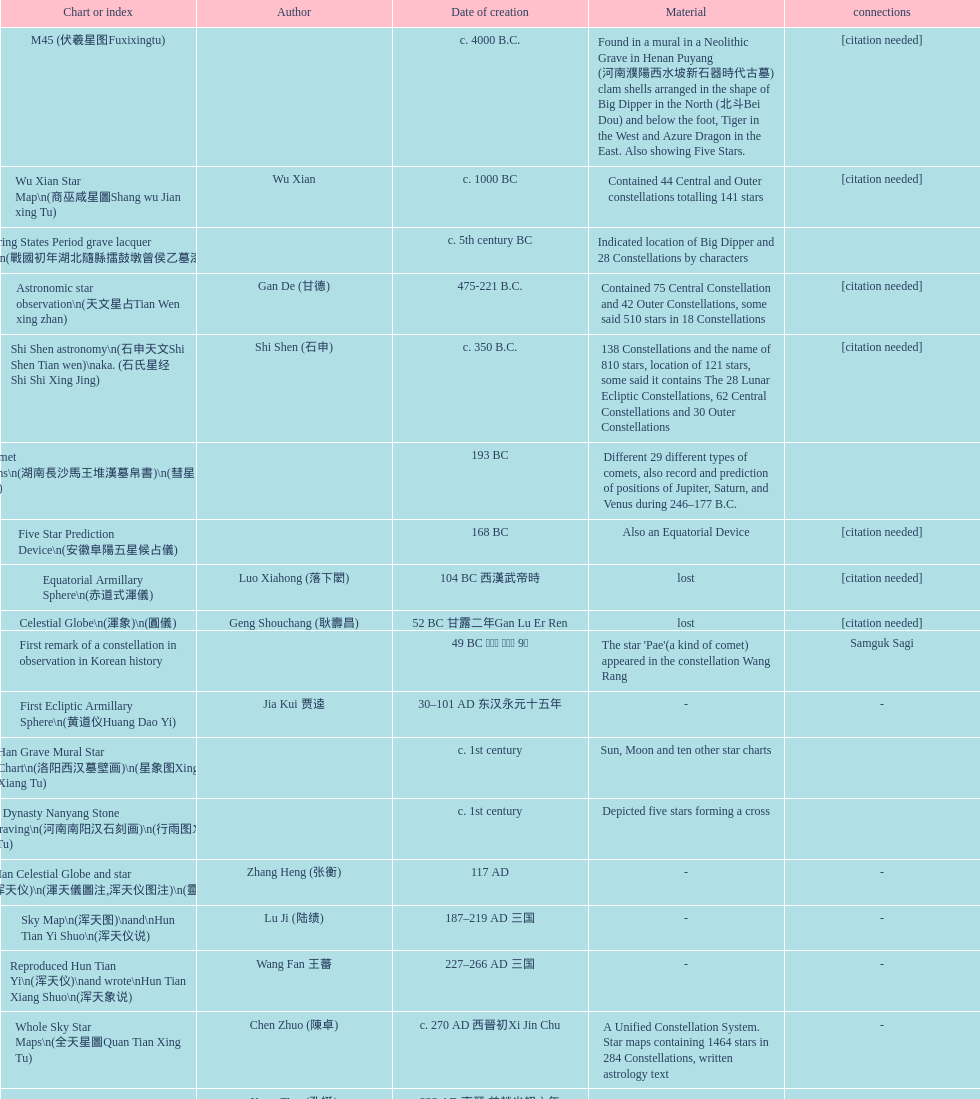What is the difference between the five star prediction device's date of creation and the han comet diagrams' date of creation? 25 years. 